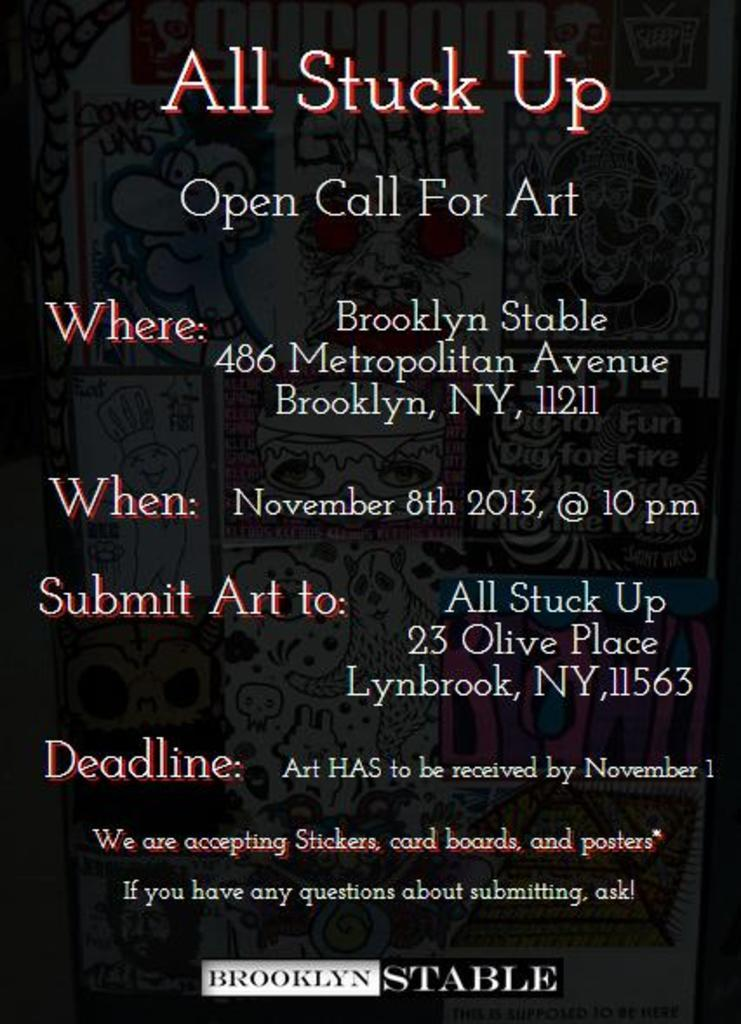<image>
Create a compact narrative representing the image presented. An advertisement announces an open call for art in Brooklyn. 